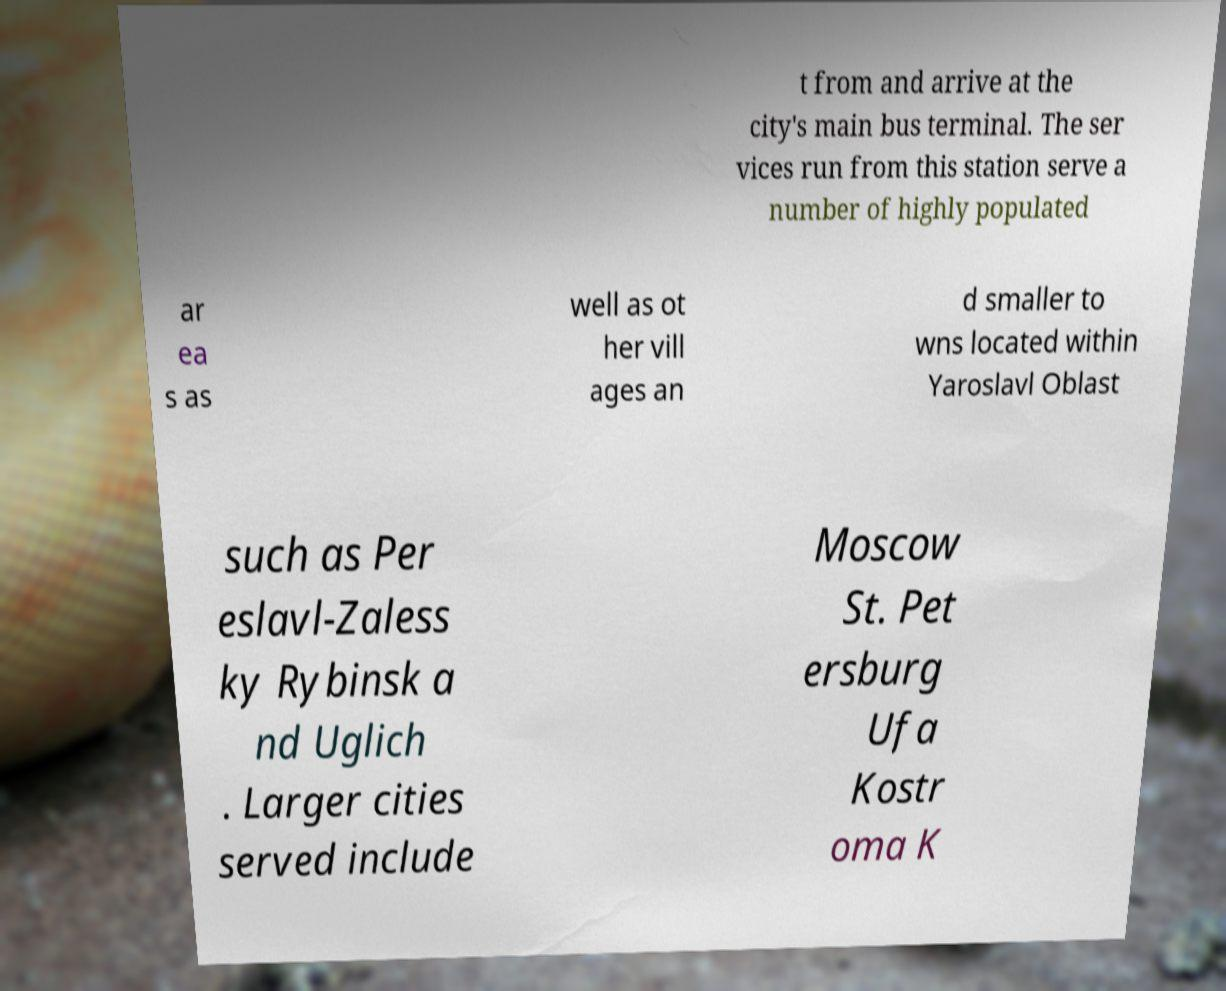Can you accurately transcribe the text from the provided image for me? t from and arrive at the city's main bus terminal. The ser vices run from this station serve a number of highly populated ar ea s as well as ot her vill ages an d smaller to wns located within Yaroslavl Oblast such as Per eslavl-Zaless ky Rybinsk a nd Uglich . Larger cities served include Moscow St. Pet ersburg Ufa Kostr oma K 